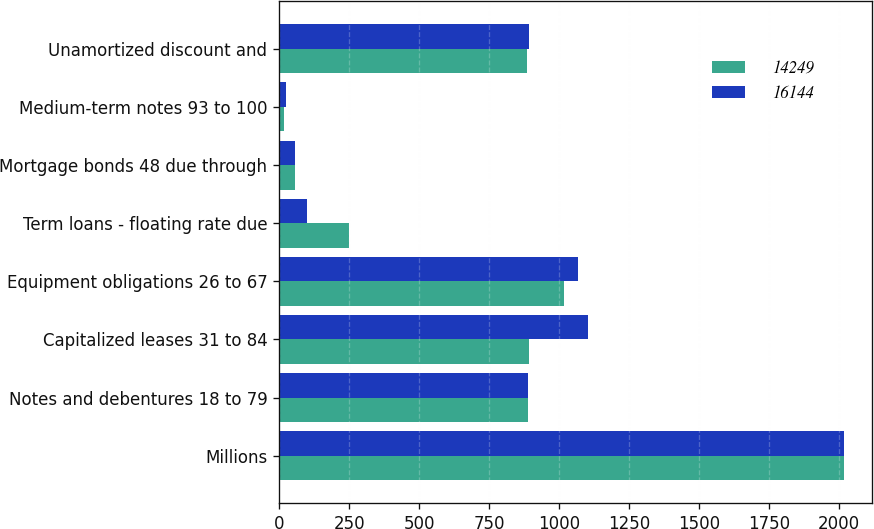<chart> <loc_0><loc_0><loc_500><loc_500><stacked_bar_chart><ecel><fcel>Millions<fcel>Notes and debentures 18 to 79<fcel>Capitalized leases 31 to 84<fcel>Equipment obligations 26 to 67<fcel>Term loans - floating rate due<fcel>Mortgage bonds 48 due through<fcel>Medium-term notes 93 to 100<fcel>Unamortized discount and<nl><fcel>14249<fcel>2017<fcel>889.5<fcel>892<fcel>1018<fcel>250<fcel>57<fcel>18<fcel>887<nl><fcel>16144<fcel>2016<fcel>889.5<fcel>1105<fcel>1069<fcel>100<fcel>57<fcel>23<fcel>894<nl></chart> 